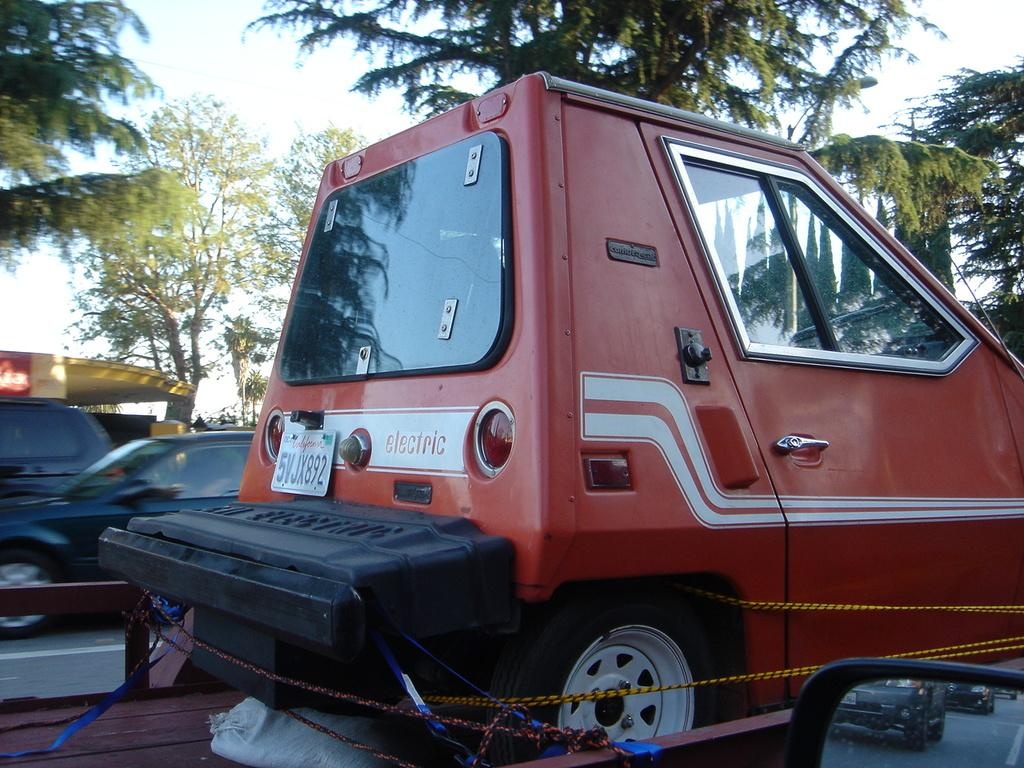What can be seen on the road in the image? There are vehicles on the road in the image. What type of natural scenery is visible in the background of the image? There are trees in the background of the image. What part of the natural environment is visible in the image? The sky is visible in the background of the image. Where is the vase located in the image? There is no vase present in the image. What type of note can be seen attached to the trees in the image? There are no notes present in the image; it features vehicles on the road and trees in the background. 